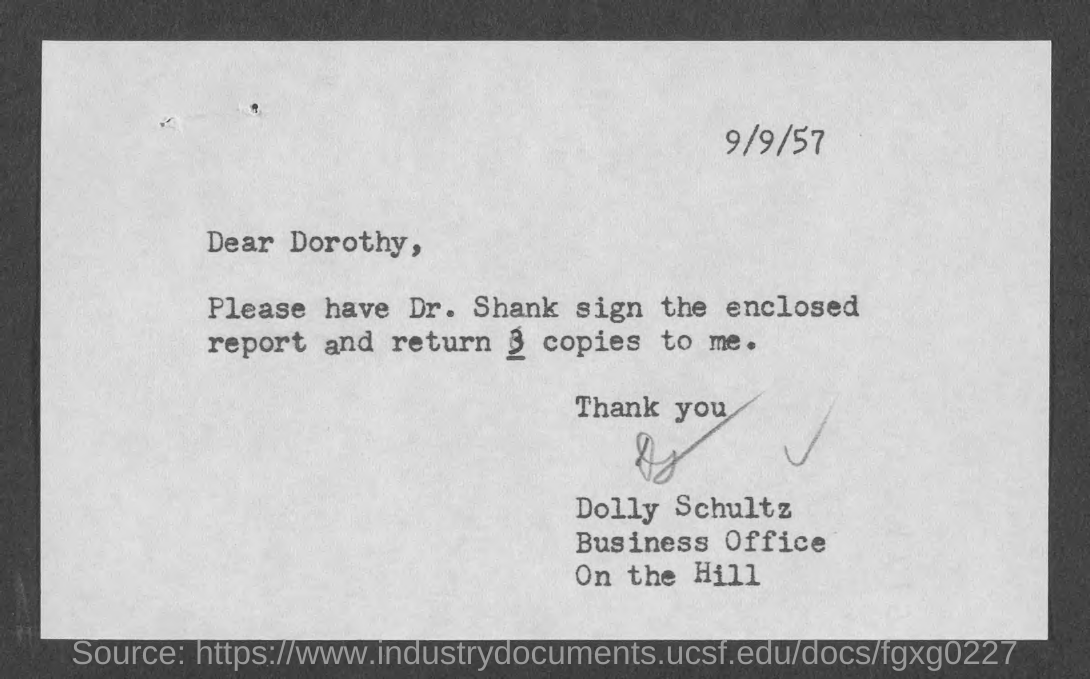Specify some key components in this picture. It is recommended that 3 copies of the document should be returned. The letter is addressed to Dorothy. The sender is Dolly Schultz. The document is dated September 9, 1957. 